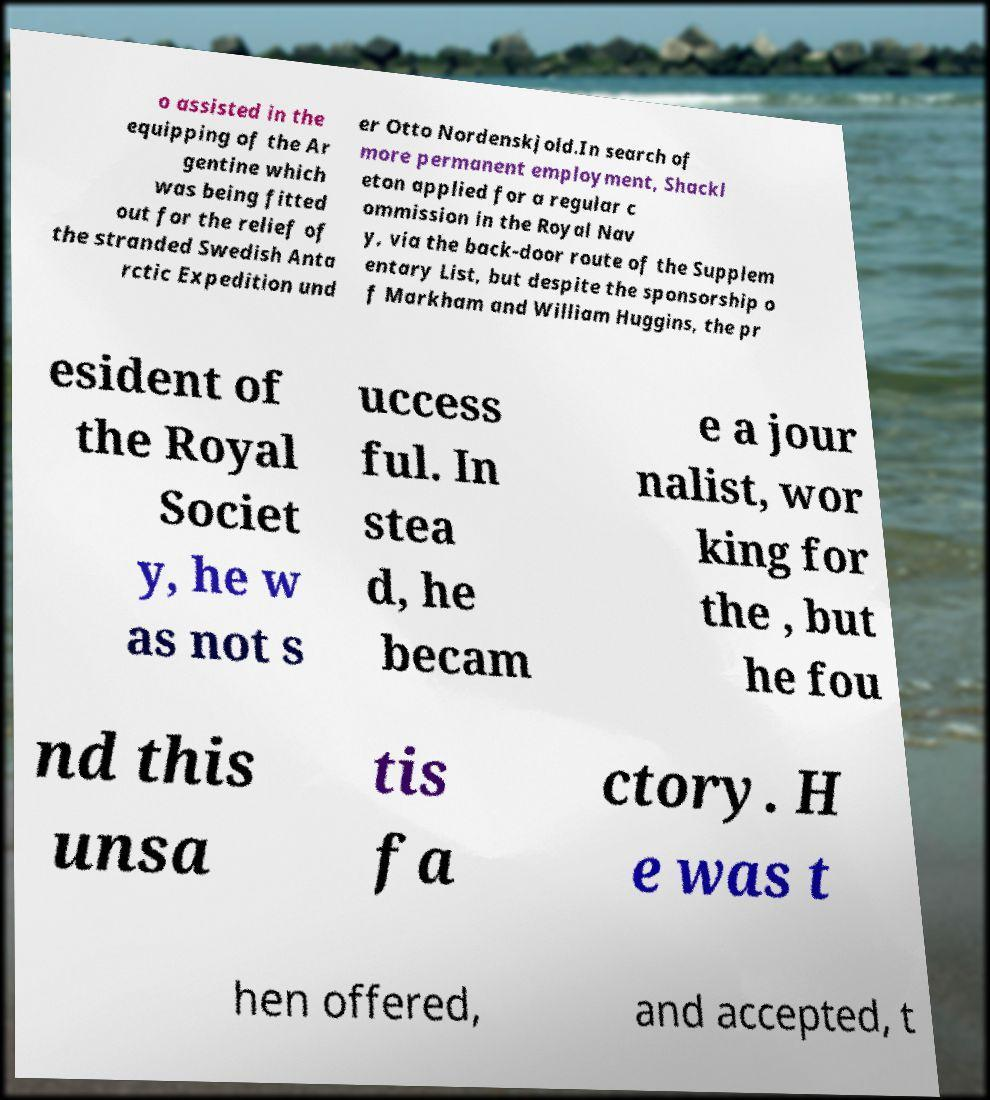There's text embedded in this image that I need extracted. Can you transcribe it verbatim? o assisted in the equipping of the Ar gentine which was being fitted out for the relief of the stranded Swedish Anta rctic Expedition und er Otto Nordenskjold.In search of more permanent employment, Shackl eton applied for a regular c ommission in the Royal Nav y, via the back-door route of the Supplem entary List, but despite the sponsorship o f Markham and William Huggins, the pr esident of the Royal Societ y, he w as not s uccess ful. In stea d, he becam e a jour nalist, wor king for the , but he fou nd this unsa tis fa ctory. H e was t hen offered, and accepted, t 